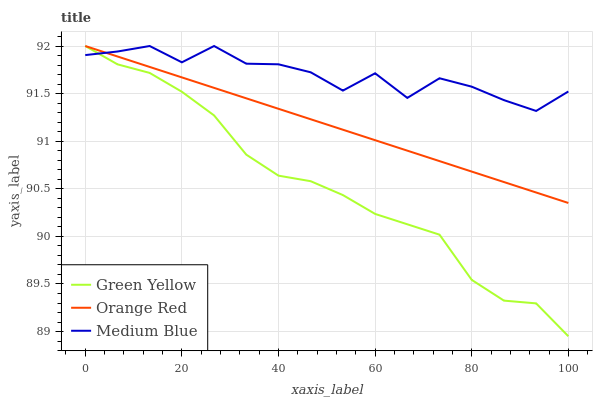Does Orange Red have the minimum area under the curve?
Answer yes or no. No. Does Orange Red have the maximum area under the curve?
Answer yes or no. No. Is Medium Blue the smoothest?
Answer yes or no. No. Is Orange Red the roughest?
Answer yes or no. No. Does Orange Red have the lowest value?
Answer yes or no. No. 